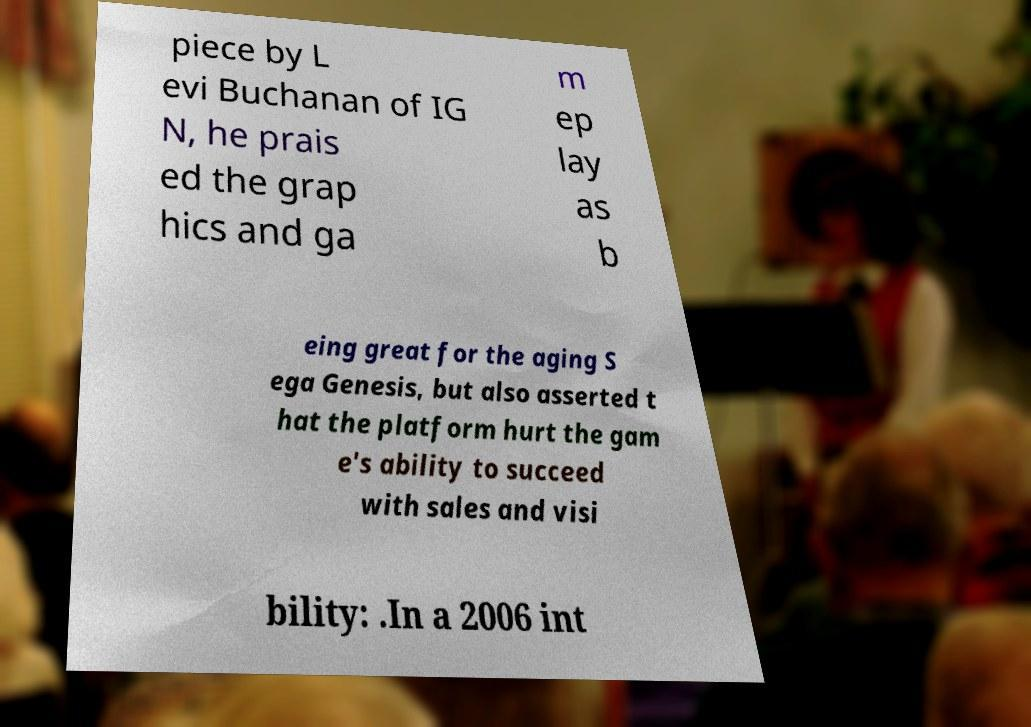Can you accurately transcribe the text from the provided image for me? piece by L evi Buchanan of IG N, he prais ed the grap hics and ga m ep lay as b eing great for the aging S ega Genesis, but also asserted t hat the platform hurt the gam e's ability to succeed with sales and visi bility: .In a 2006 int 